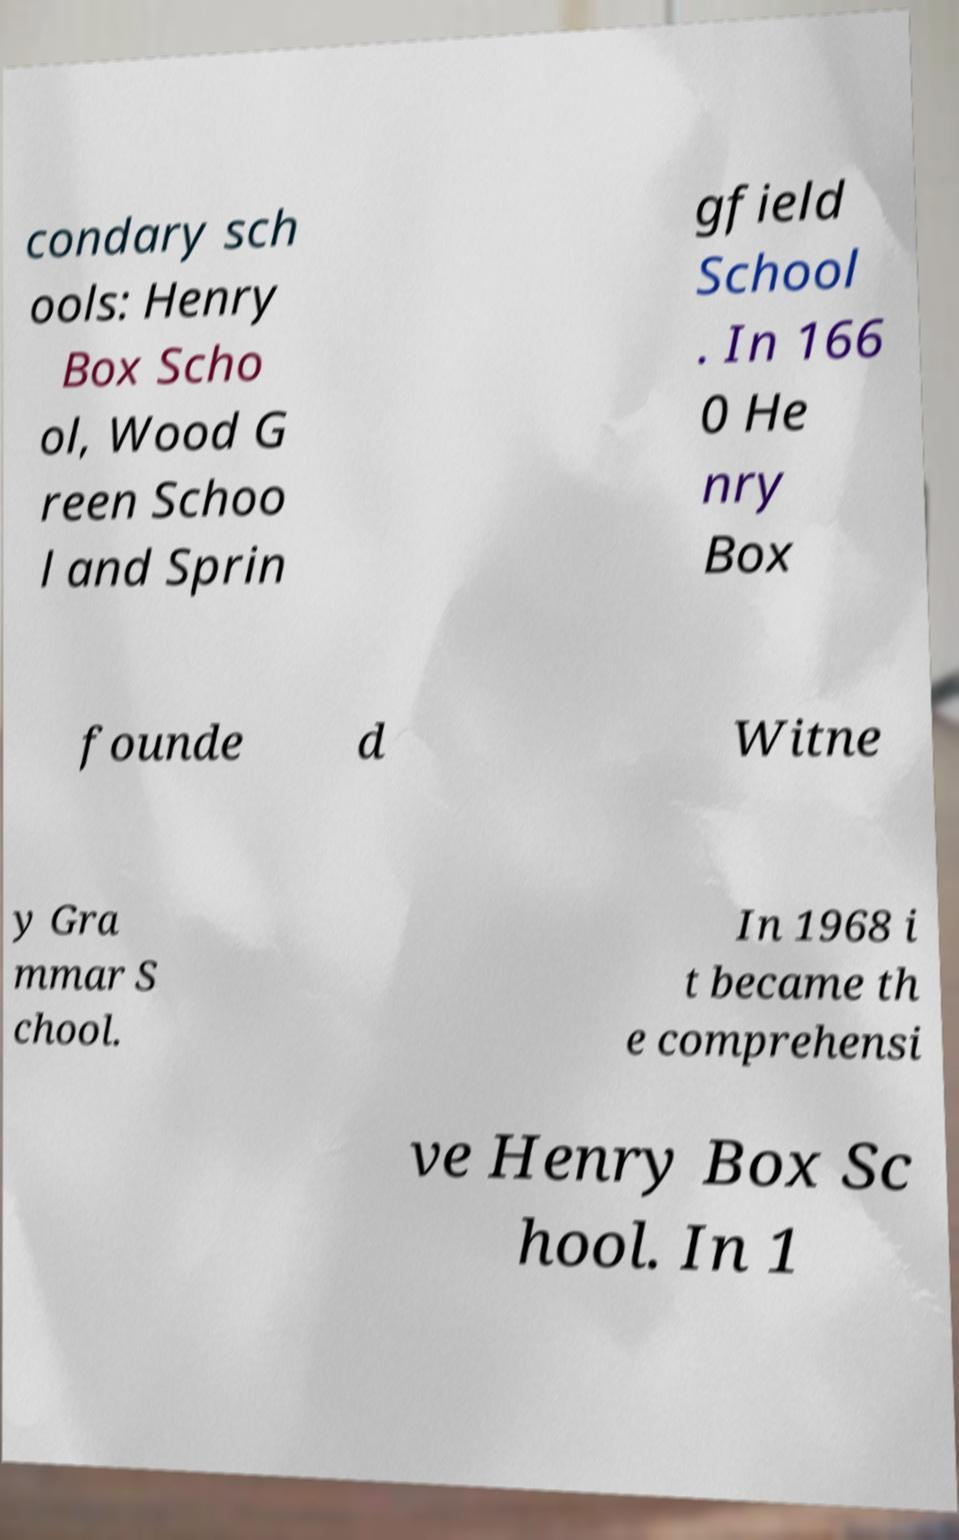What messages or text are displayed in this image? I need them in a readable, typed format. condary sch ools: Henry Box Scho ol, Wood G reen Schoo l and Sprin gfield School . In 166 0 He nry Box founde d Witne y Gra mmar S chool. In 1968 i t became th e comprehensi ve Henry Box Sc hool. In 1 